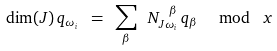<formula> <loc_0><loc_0><loc_500><loc_500>\dim ( J ) \, q _ { \omega _ { i } } \ = \ \sum _ { \beta } \ N ^ { \ \beta } _ { J \omega _ { i } } \, q _ { \beta } \ \mod \ x</formula> 